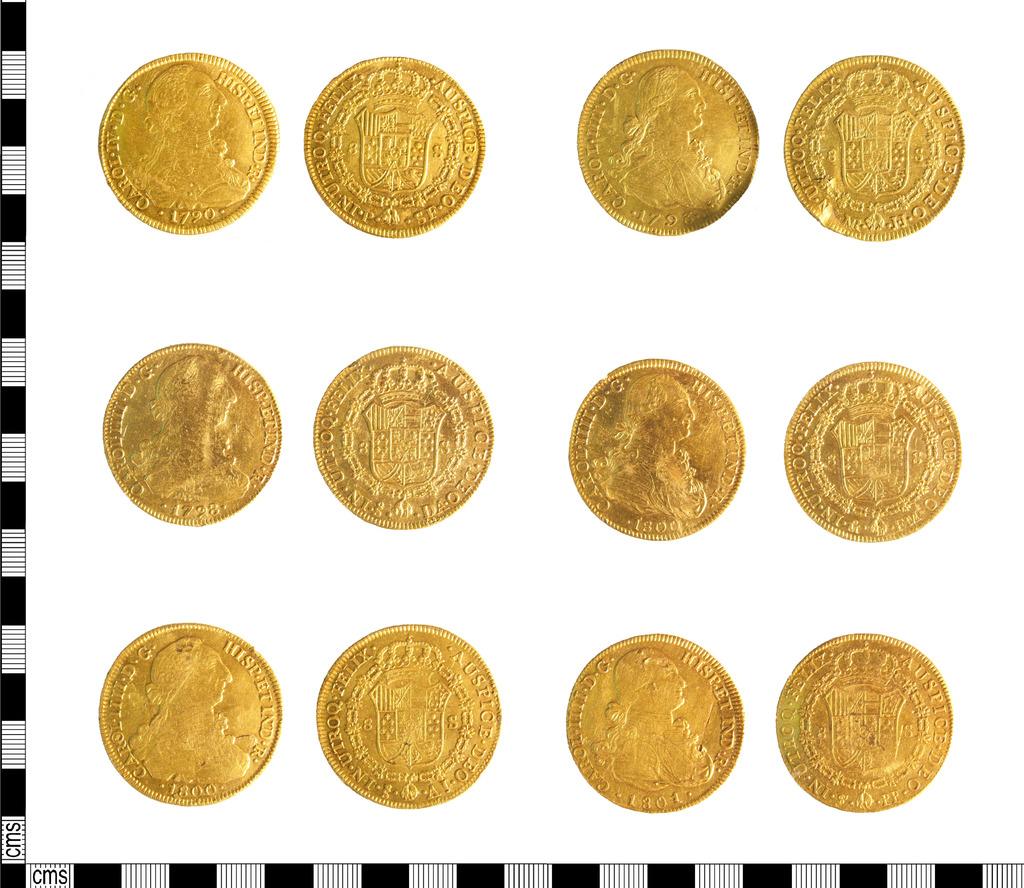What year is the upper-left coin?
Offer a very short reply. 1790. 